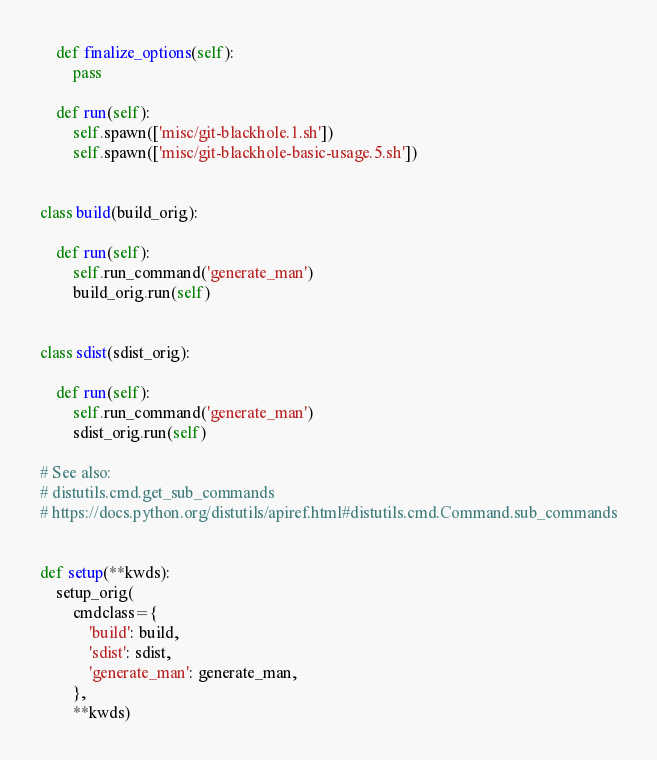<code> <loc_0><loc_0><loc_500><loc_500><_Python_>    def finalize_options(self):
        pass

    def run(self):
        self.spawn(['misc/git-blackhole.1.sh'])
        self.spawn(['misc/git-blackhole-basic-usage.5.sh'])


class build(build_orig):

    def run(self):
        self.run_command('generate_man')
        build_orig.run(self)


class sdist(sdist_orig):

    def run(self):
        self.run_command('generate_man')
        sdist_orig.run(self)

# See also:
# distutils.cmd.get_sub_commands
# https://docs.python.org/distutils/apiref.html#distutils.cmd.Command.sub_commands


def setup(**kwds):
    setup_orig(
        cmdclass={
            'build': build,
            'sdist': sdist,
            'generate_man': generate_man,
        },
        **kwds)
</code> 